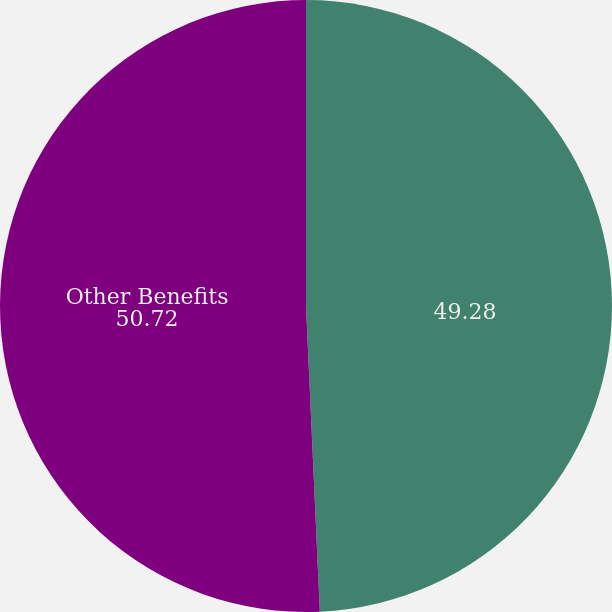<chart> <loc_0><loc_0><loc_500><loc_500><pie_chart><ecel><fcel>Other Benefits<nl><fcel>49.28%<fcel>50.72%<nl></chart> 